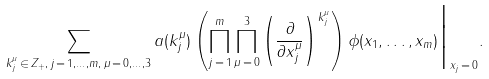Convert formula to latex. <formula><loc_0><loc_0><loc_500><loc_500>\sum _ { k _ { j } ^ { \mu } \, \in \, { Z } _ { + } , \, j \, = \, 1 , \dots , m , \, \mu \, = \, 0 , \dots , 3 } a ( k _ { j } ^ { \mu } ) \left ( \prod _ { j \, = \, 1 } ^ { m } \prod _ { \mu \, = \, 0 } ^ { 3 } \left ( \frac { \partial } { \partial x _ { j } ^ { \mu } } \right ) ^ { k _ { j } ^ { \mu } } \right ) \phi ( x _ { 1 } , \dots , x _ { m } ) \Big | _ { x _ { j } \, = \, 0 } .</formula> 